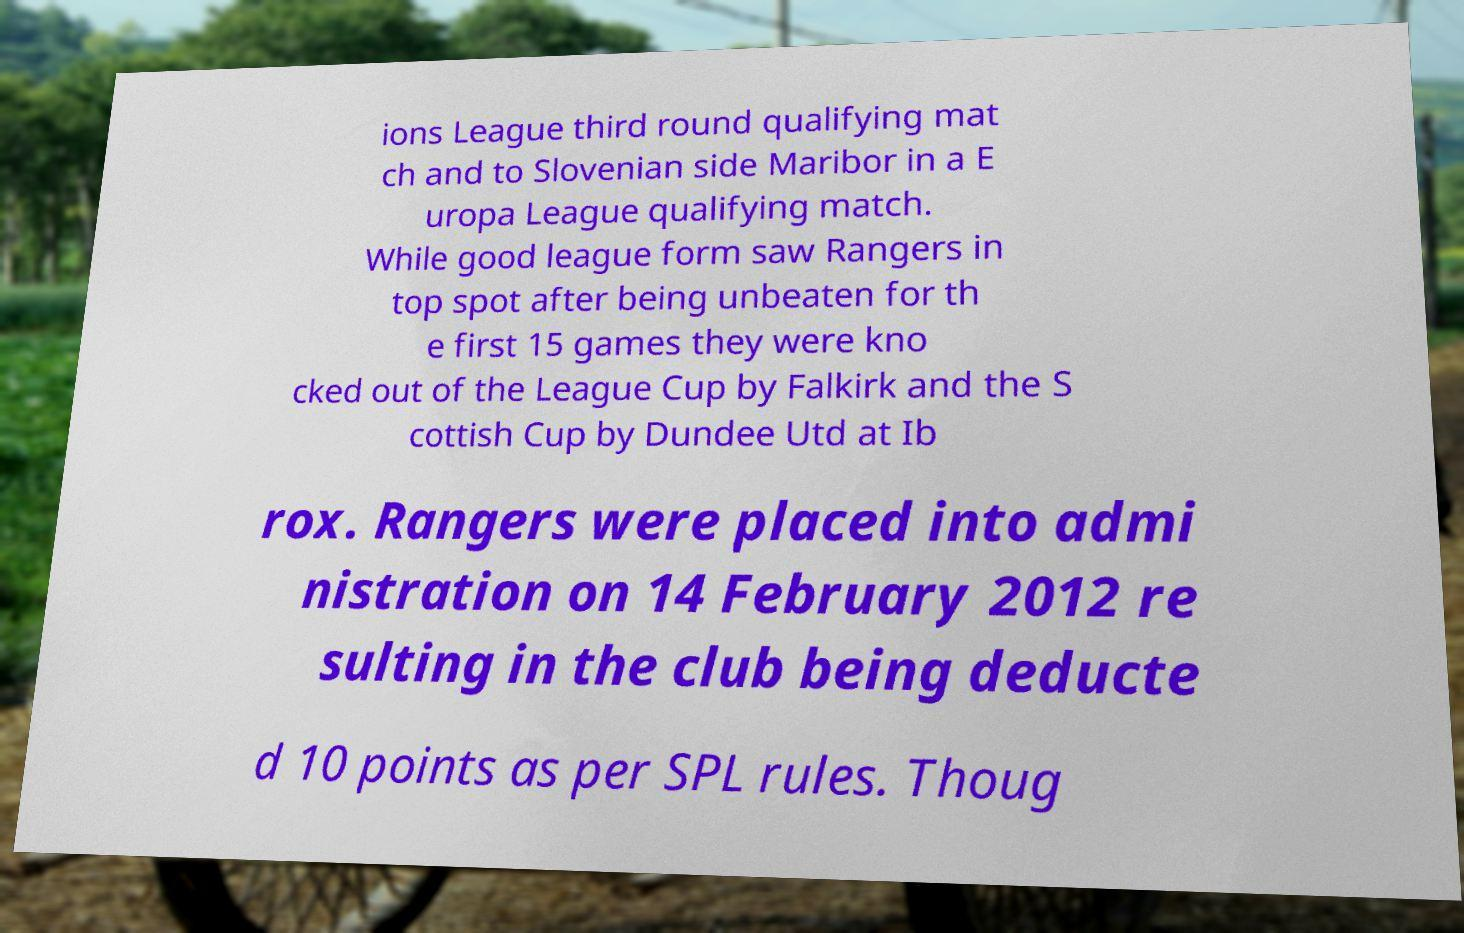What messages or text are displayed in this image? I need them in a readable, typed format. ions League third round qualifying mat ch and to Slovenian side Maribor in a E uropa League qualifying match. While good league form saw Rangers in top spot after being unbeaten for th e first 15 games they were kno cked out of the League Cup by Falkirk and the S cottish Cup by Dundee Utd at Ib rox. Rangers were placed into admi nistration on 14 February 2012 re sulting in the club being deducte d 10 points as per SPL rules. Thoug 